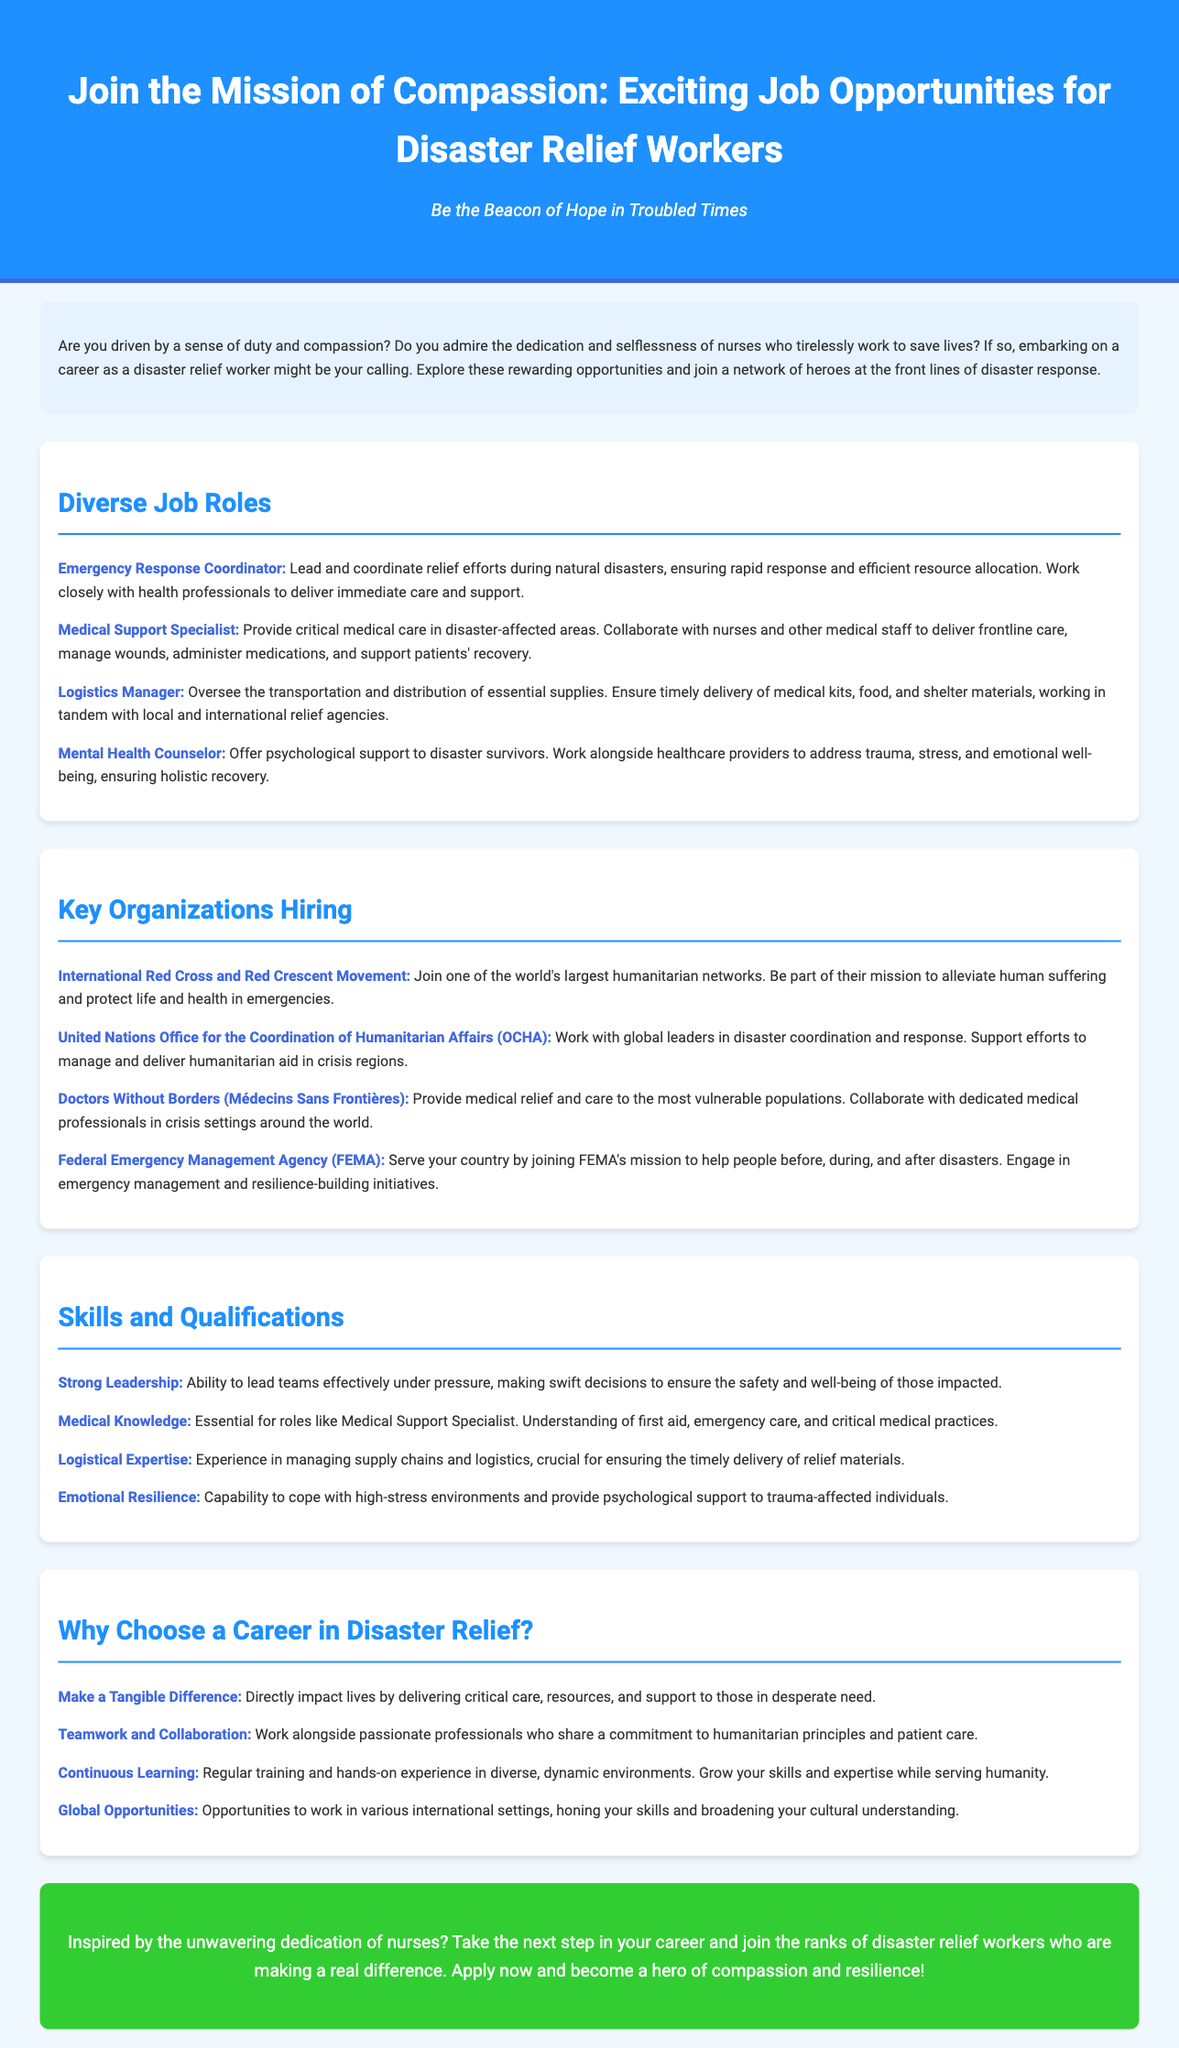what is the title of the advertisement? The title of the advertisement is prominently displayed in the header section of the document.
Answer: Join the Mission of Compassion: Exciting Job Opportunities for Disaster Relief Workers how many diverse job roles are listed? The document lists a total of four distinct roles under the "Diverse Job Roles" section.
Answer: Four which organization offers global humanitarian aid? One of the organizations mentioned that offers such aid is highlighted in the "Key Organizations Hiring" section.
Answer: Doctors Without Borders (Médecins Sans Frontières) what skill is essential for a Medical Support Specialist? A key qualification for the role of Medical Support Specialist is mentioned in the "Skills and Qualifications" section.
Answer: Medical Knowledge what is a reason to choose a career in disaster relief? Several compelling reasons are provided in the document, with one highlighted under the "Why Choose a Career in Disaster Relief?" section.
Answer: Make a Tangible Difference who is encouraged to apply for these jobs? The document specifically encourages individuals who admire a certain profession to consider applying.
Answer: Nurses 